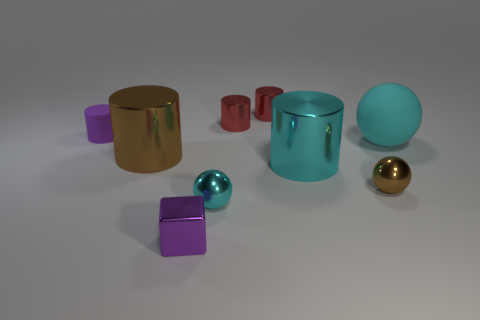Do the small matte cylinder and the small cube have the same color?
Your answer should be very brief. Yes. Are there the same number of cyan metal spheres that are behind the large cyan rubber thing and blue rubber cylinders?
Ensure brevity in your answer.  Yes. There is a metallic ball that is the same color as the large matte object; what size is it?
Provide a succinct answer. Small. Do the purple rubber object and the large cyan shiny object have the same shape?
Provide a short and direct response. Yes. How many objects are matte objects that are in front of the purple matte object or tiny metallic spheres?
Offer a terse response. 3. Are there an equal number of purple cylinders that are on the right side of the purple matte cylinder and large cyan metal things right of the brown sphere?
Make the answer very short. Yes. How many other things are the same shape as the purple shiny object?
Your answer should be very brief. 0. There is a purple object in front of the purple cylinder; does it have the same size as the brown thing in front of the large brown cylinder?
Give a very brief answer. Yes. What number of cubes are either big shiny things or red metallic things?
Give a very brief answer. 0. How many matte objects are large gray cylinders or brown things?
Ensure brevity in your answer.  0. 